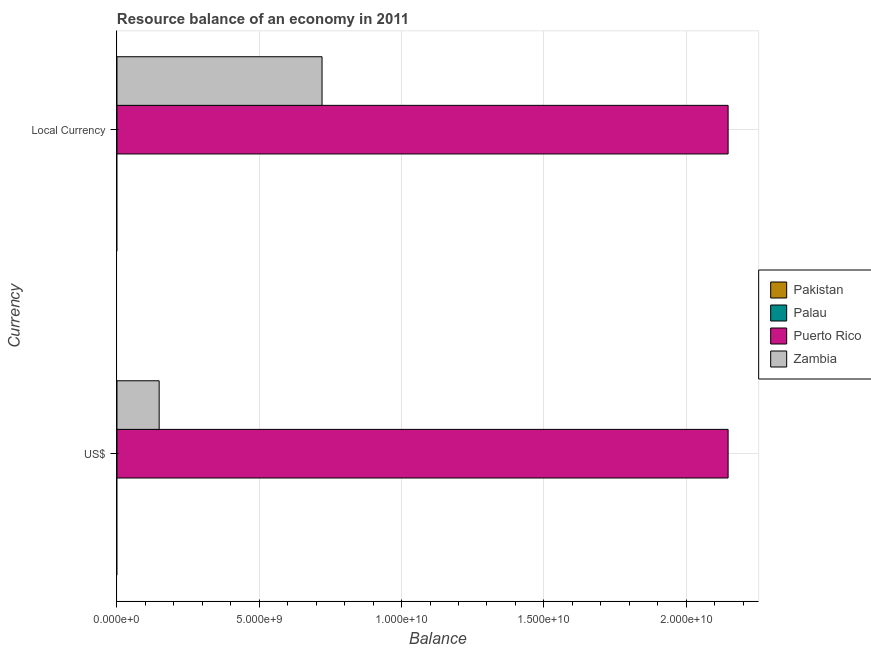Are the number of bars per tick equal to the number of legend labels?
Provide a short and direct response. No. Are the number of bars on each tick of the Y-axis equal?
Provide a short and direct response. Yes. How many bars are there on the 1st tick from the top?
Provide a short and direct response. 2. How many bars are there on the 2nd tick from the bottom?
Your answer should be compact. 2. What is the label of the 1st group of bars from the top?
Provide a succinct answer. Local Currency. What is the resource balance in us$ in Zambia?
Your answer should be compact. 1.48e+09. Across all countries, what is the maximum resource balance in constant us$?
Provide a short and direct response. 2.15e+1. Across all countries, what is the minimum resource balance in us$?
Give a very brief answer. 0. In which country was the resource balance in us$ maximum?
Keep it short and to the point. Puerto Rico. What is the total resource balance in constant us$ in the graph?
Provide a succinct answer. 2.87e+1. What is the difference between the resource balance in constant us$ in Puerto Rico and that in Zambia?
Ensure brevity in your answer.  1.43e+1. What is the difference between the resource balance in constant us$ in Zambia and the resource balance in us$ in Pakistan?
Make the answer very short. 7.21e+09. What is the average resource balance in us$ per country?
Give a very brief answer. 5.74e+09. What is the ratio of the resource balance in us$ in Puerto Rico to that in Zambia?
Your answer should be compact. 14.49. How many bars are there?
Provide a succinct answer. 4. What is the difference between two consecutive major ticks on the X-axis?
Your answer should be very brief. 5.00e+09. Does the graph contain any zero values?
Make the answer very short. Yes. Does the graph contain grids?
Your answer should be compact. Yes. Where does the legend appear in the graph?
Offer a terse response. Center right. How are the legend labels stacked?
Ensure brevity in your answer.  Vertical. What is the title of the graph?
Keep it short and to the point. Resource balance of an economy in 2011. Does "High income" appear as one of the legend labels in the graph?
Offer a very short reply. No. What is the label or title of the X-axis?
Your answer should be very brief. Balance. What is the label or title of the Y-axis?
Your answer should be compact. Currency. What is the Balance of Pakistan in US$?
Your answer should be compact. 0. What is the Balance in Puerto Rico in US$?
Make the answer very short. 2.15e+1. What is the Balance in Zambia in US$?
Ensure brevity in your answer.  1.48e+09. What is the Balance in Pakistan in Local Currency?
Provide a short and direct response. 0. What is the Balance in Palau in Local Currency?
Your answer should be compact. 0. What is the Balance of Puerto Rico in Local Currency?
Make the answer very short. 2.15e+1. What is the Balance in Zambia in Local Currency?
Your response must be concise. 7.21e+09. Across all Currency, what is the maximum Balance of Puerto Rico?
Offer a very short reply. 2.15e+1. Across all Currency, what is the maximum Balance of Zambia?
Offer a terse response. 7.21e+09. Across all Currency, what is the minimum Balance of Puerto Rico?
Keep it short and to the point. 2.15e+1. Across all Currency, what is the minimum Balance in Zambia?
Make the answer very short. 1.48e+09. What is the total Balance of Pakistan in the graph?
Provide a succinct answer. 0. What is the total Balance of Palau in the graph?
Your answer should be compact. 0. What is the total Balance in Puerto Rico in the graph?
Make the answer very short. 4.29e+1. What is the total Balance of Zambia in the graph?
Your response must be concise. 8.69e+09. What is the difference between the Balance of Puerto Rico in US$ and that in Local Currency?
Offer a very short reply. 0. What is the difference between the Balance in Zambia in US$ and that in Local Currency?
Give a very brief answer. -5.72e+09. What is the difference between the Balance of Puerto Rico in US$ and the Balance of Zambia in Local Currency?
Your answer should be compact. 1.43e+1. What is the average Balance of Palau per Currency?
Your answer should be very brief. 0. What is the average Balance in Puerto Rico per Currency?
Provide a short and direct response. 2.15e+1. What is the average Balance of Zambia per Currency?
Offer a terse response. 4.34e+09. What is the difference between the Balance of Puerto Rico and Balance of Zambia in US$?
Offer a very short reply. 2.00e+1. What is the difference between the Balance in Puerto Rico and Balance in Zambia in Local Currency?
Ensure brevity in your answer.  1.43e+1. What is the ratio of the Balance in Zambia in US$ to that in Local Currency?
Ensure brevity in your answer.  0.21. What is the difference between the highest and the second highest Balance in Zambia?
Provide a short and direct response. 5.72e+09. What is the difference between the highest and the lowest Balance in Zambia?
Your answer should be very brief. 5.72e+09. 